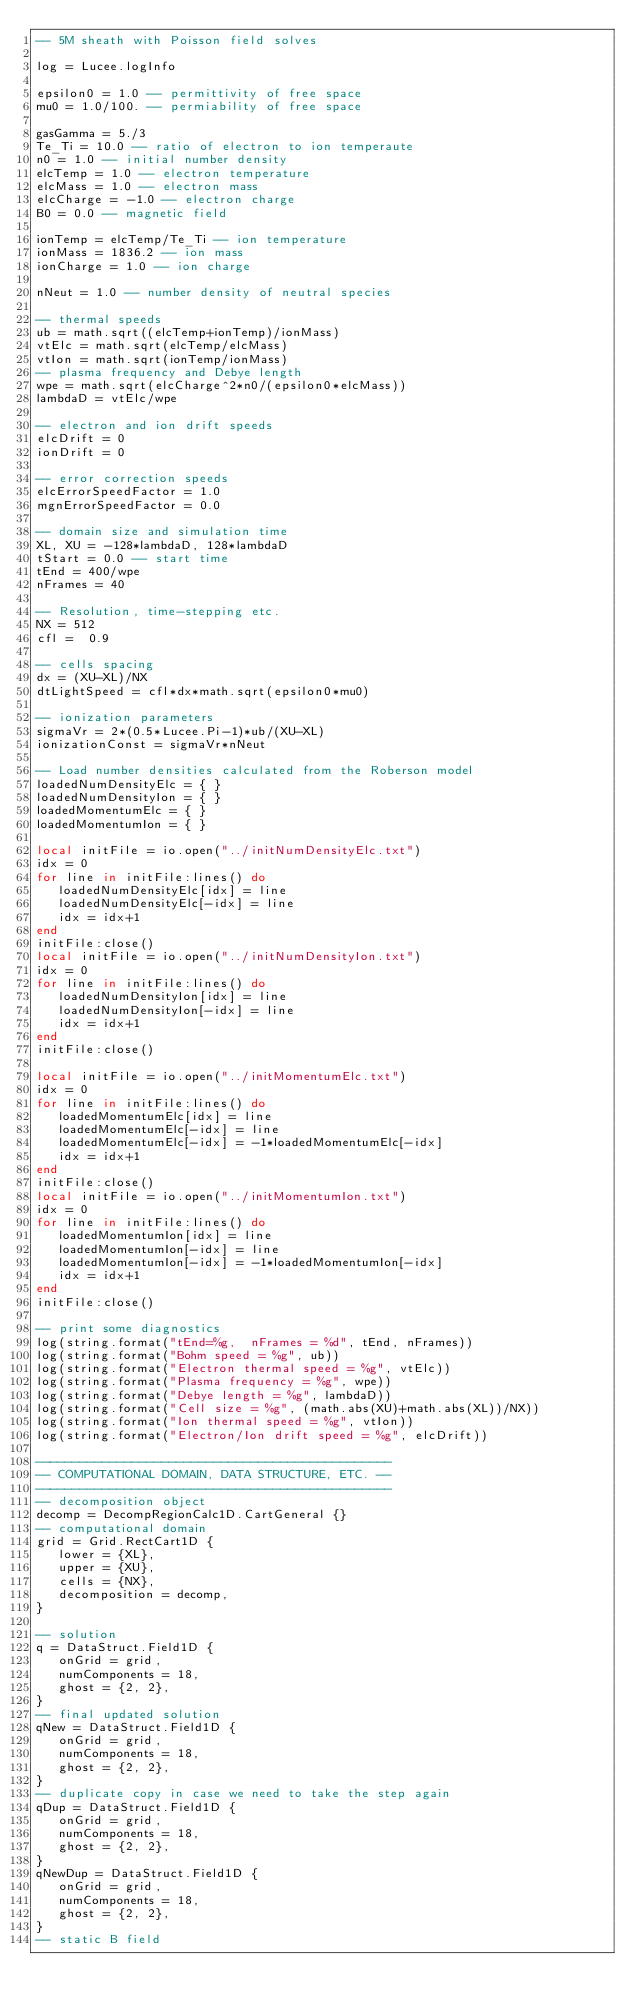Convert code to text. <code><loc_0><loc_0><loc_500><loc_500><_Lua_>-- 5M sheath with Poisson field solves

log = Lucee.logInfo

epsilon0 = 1.0 -- permittivity of free space
mu0 = 1.0/100. -- permiability of free space

gasGamma = 5./3
Te_Ti = 10.0 -- ratio of electron to ion temperaute
n0 = 1.0 -- initial number density
elcTemp = 1.0 -- electron temperature
elcMass = 1.0 -- electron mass
elcCharge = -1.0 -- electron charge
B0 = 0.0 -- magnetic field

ionTemp = elcTemp/Te_Ti -- ion temperature
ionMass = 1836.2 -- ion mass
ionCharge = 1.0 -- ion charge

nNeut = 1.0 -- number density of neutral species

-- thermal speeds
ub = math.sqrt((elcTemp+ionTemp)/ionMass)
vtElc = math.sqrt(elcTemp/elcMass)
vtIon = math.sqrt(ionTemp/ionMass)
-- plasma frequency and Debye length
wpe = math.sqrt(elcCharge^2*n0/(epsilon0*elcMass))
lambdaD = vtElc/wpe

-- electron and ion drift speeds
elcDrift = 0
ionDrift = 0

-- error correction speeds
elcErrorSpeedFactor = 1.0
mgnErrorSpeedFactor = 0.0

-- domain size and simulation time
XL, XU = -128*lambdaD, 128*lambdaD
tStart = 0.0 -- start time 
tEnd = 400/wpe
nFrames = 40

-- Resolution, time-stepping etc.
NX = 512
cfl =  0.9

-- cells spacing
dx = (XU-XL)/NX
dtLightSpeed = cfl*dx*math.sqrt(epsilon0*mu0)

-- ionization parameters
sigmaVr = 2*(0.5*Lucee.Pi-1)*ub/(XU-XL)
ionizationConst = sigmaVr*nNeut

-- Load number densities calculated from the Roberson model
loadedNumDensityElc = { }
loadedNumDensityIon = { }
loadedMomentumElc = { }
loadedMomentumIon = { }

local initFile = io.open("../initNumDensityElc.txt")
idx = 0
for line in initFile:lines() do
   loadedNumDensityElc[idx] = line
   loadedNumDensityElc[-idx] = line
   idx = idx+1
end
initFile:close()
local initFile = io.open("../initNumDensityIon.txt")
idx = 0
for line in initFile:lines() do
   loadedNumDensityIon[idx] = line
   loadedNumDensityIon[-idx] = line
   idx = idx+1
end
initFile:close()

local initFile = io.open("../initMomentumElc.txt")
idx = 0
for line in initFile:lines() do
   loadedMomentumElc[idx] = line
   loadedMomentumElc[-idx] = line
   loadedMomentumElc[-idx] = -1*loadedMomentumElc[-idx]
   idx = idx+1
end
initFile:close()
local initFile = io.open("../initMomentumIon.txt")
idx = 0
for line in initFile:lines() do
   loadedMomentumIon[idx] = line
   loadedMomentumIon[-idx] = line
   loadedMomentumIon[-idx] = -1*loadedMomentumIon[-idx]
   idx = idx+1
end
initFile:close()

-- print some diagnostics
log(string.format("tEnd=%g,  nFrames = %d", tEnd, nFrames))
log(string.format("Bohm speed = %g", ub))
log(string.format("Electron thermal speed = %g", vtElc))
log(string.format("Plasma frequency = %g", wpe))
log(string.format("Debye length = %g", lambdaD))
log(string.format("Cell size = %g", (math.abs(XU)+math.abs(XL))/NX))
log(string.format("Ion thermal speed = %g", vtIon))
log(string.format("Electron/Ion drift speed = %g", elcDrift))

------------------------------------------------
-- COMPUTATIONAL DOMAIN, DATA STRUCTURE, ETC. --
------------------------------------------------
-- decomposition object
decomp = DecompRegionCalc1D.CartGeneral {}
-- computational domain
grid = Grid.RectCart1D {
   lower = {XL},
   upper = {XU},
   cells = {NX},
   decomposition = decomp,
}

-- solution
q = DataStruct.Field1D {
   onGrid = grid,
   numComponents = 18,
   ghost = {2, 2},
}
-- final updated solution
qNew = DataStruct.Field1D {
   onGrid = grid,
   numComponents = 18,
   ghost = {2, 2},
}
-- duplicate copy in case we need to take the step again
qDup = DataStruct.Field1D {
   onGrid = grid,
   numComponents = 18,
   ghost = {2, 2},
}
qNewDup = DataStruct.Field1D {
   onGrid = grid,
   numComponents = 18,
   ghost = {2, 2},
}
-- static B field</code> 